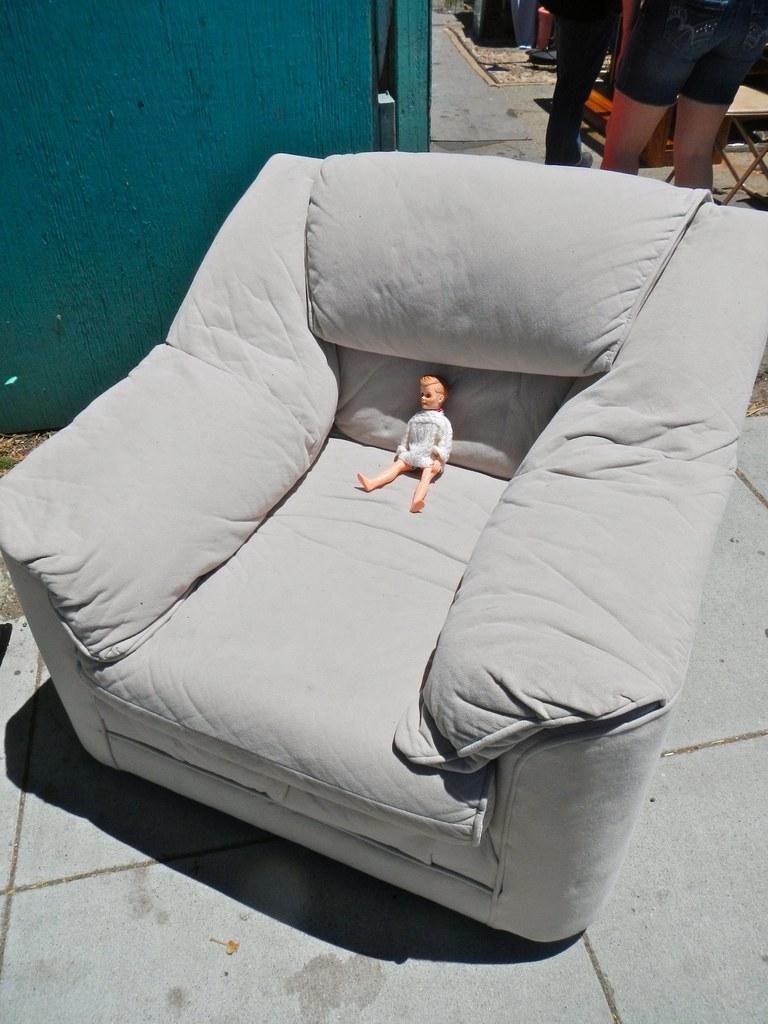Please provide a concise description of this image. There is a toy in the grey sofa and there are two people behind the sofa. 